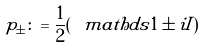Convert formula to latex. <formula><loc_0><loc_0><loc_500><loc_500>p _ { \pm } \colon = \frac { 1 } { 2 } ( \ m a t h d s { 1 } \pm i I )</formula> 